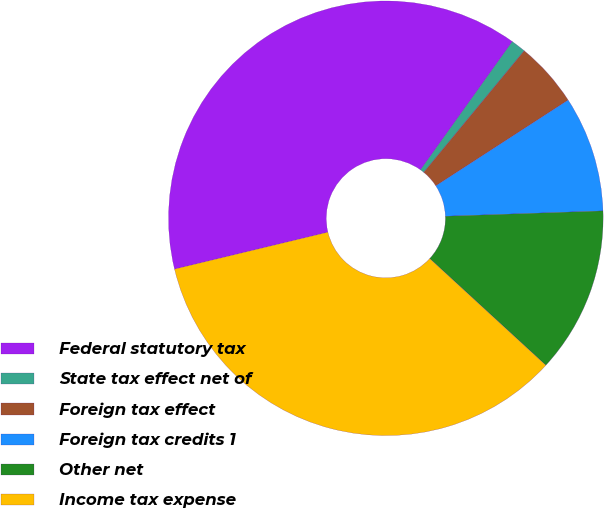Convert chart to OTSL. <chart><loc_0><loc_0><loc_500><loc_500><pie_chart><fcel>Federal statutory tax<fcel>State tax effect net of<fcel>Foreign tax effect<fcel>Foreign tax credits 1<fcel>Other net<fcel>Income tax expense<nl><fcel>38.65%<fcel>1.1%<fcel>4.86%<fcel>8.61%<fcel>12.37%<fcel>34.41%<nl></chart> 